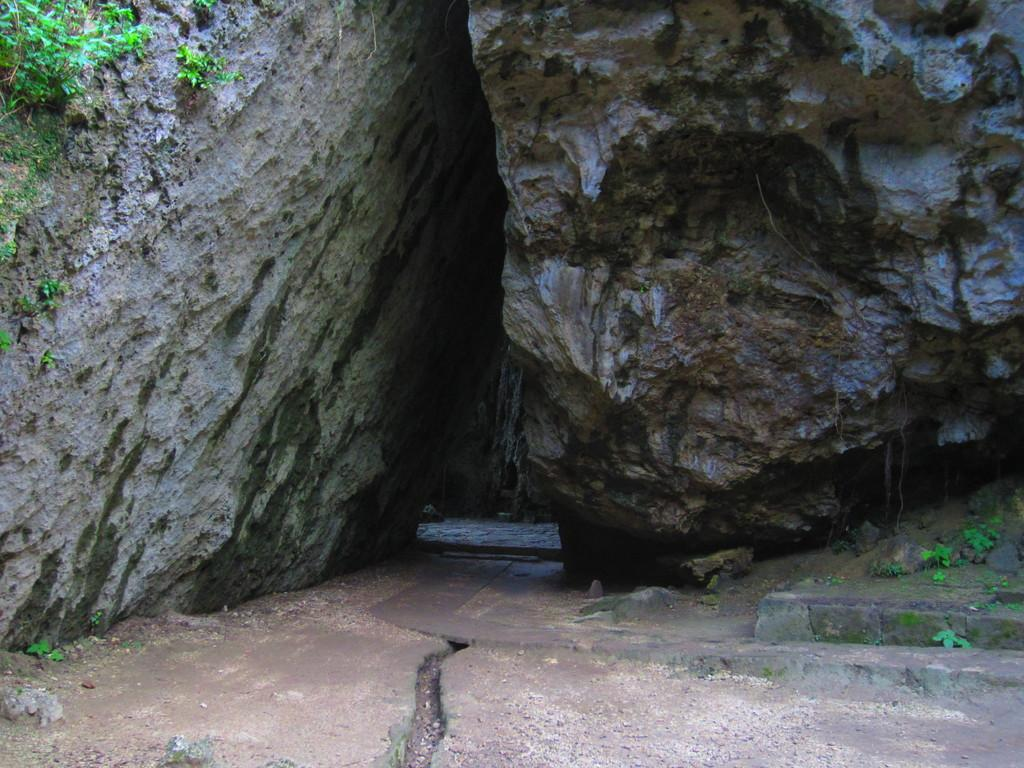What type of living organisms can be seen in the image? Plants can be seen in the image. What else is present in the image besides plants? There are rocks in the image. How many cows are visible in the image? There are no cows present in the image. Can you hear the plants crying in the image? Plants do not have the ability to cry, and there is no sound in the image. 